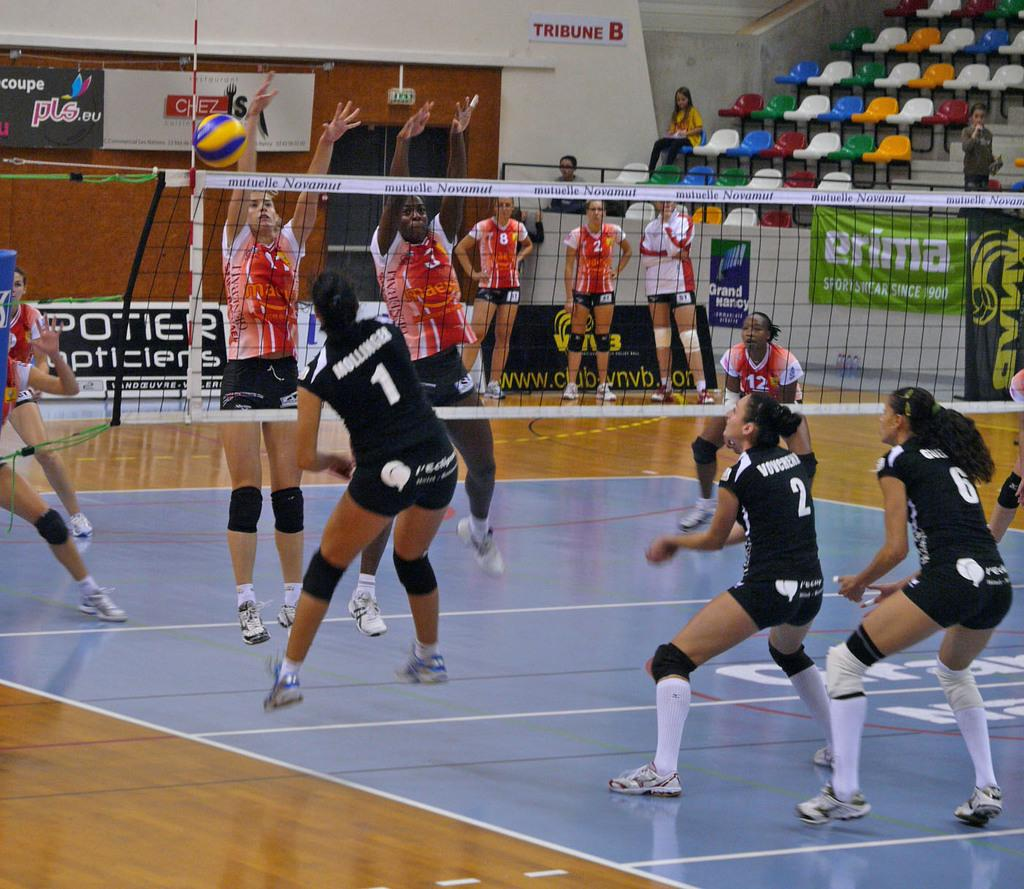<image>
Describe the image concisely. Volleyball players are wearing jersey numbers 1 an 2 